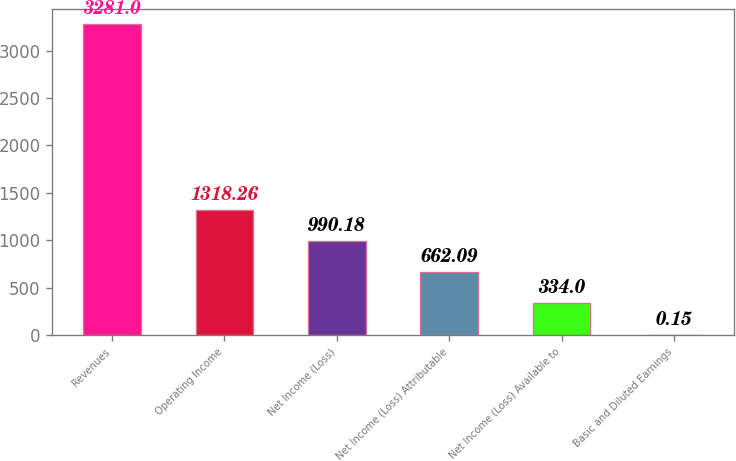Convert chart to OTSL. <chart><loc_0><loc_0><loc_500><loc_500><bar_chart><fcel>Revenues<fcel>Operating Income<fcel>Net Income (Loss)<fcel>Net Income (Loss) Attributable<fcel>Net Income (Loss) Available to<fcel>Basic and Diluted Earnings<nl><fcel>3281<fcel>1318.26<fcel>990.18<fcel>662.09<fcel>334<fcel>0.15<nl></chart> 